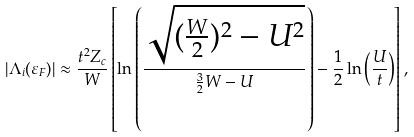<formula> <loc_0><loc_0><loc_500><loc_500>| \Lambda _ { i } ( \varepsilon _ { F } ) | \approx \frac { t ^ { 2 } Z _ { c } } { W } \left [ \ln \left ( \frac { \sqrt { ( \frac { W } { 2 } ) ^ { 2 } - U ^ { 2 } } } { \frac { 3 } { 2 } W - U } \right ) - \frac { 1 } { 2 } \ln \left ( \frac { U } { t } \right ) \right ] ,</formula> 